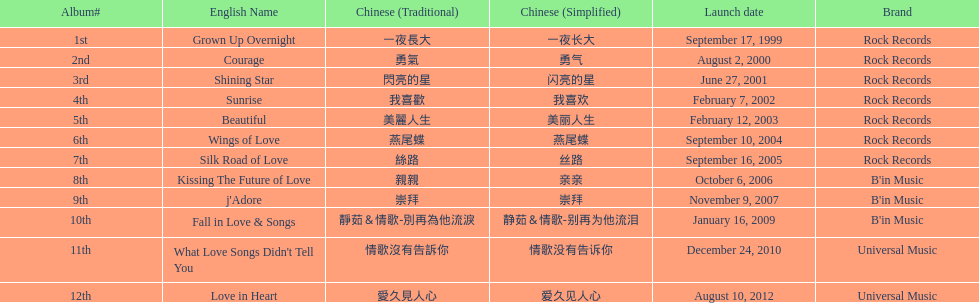What is the name of her last album produced with rock records? Silk Road of Love. 